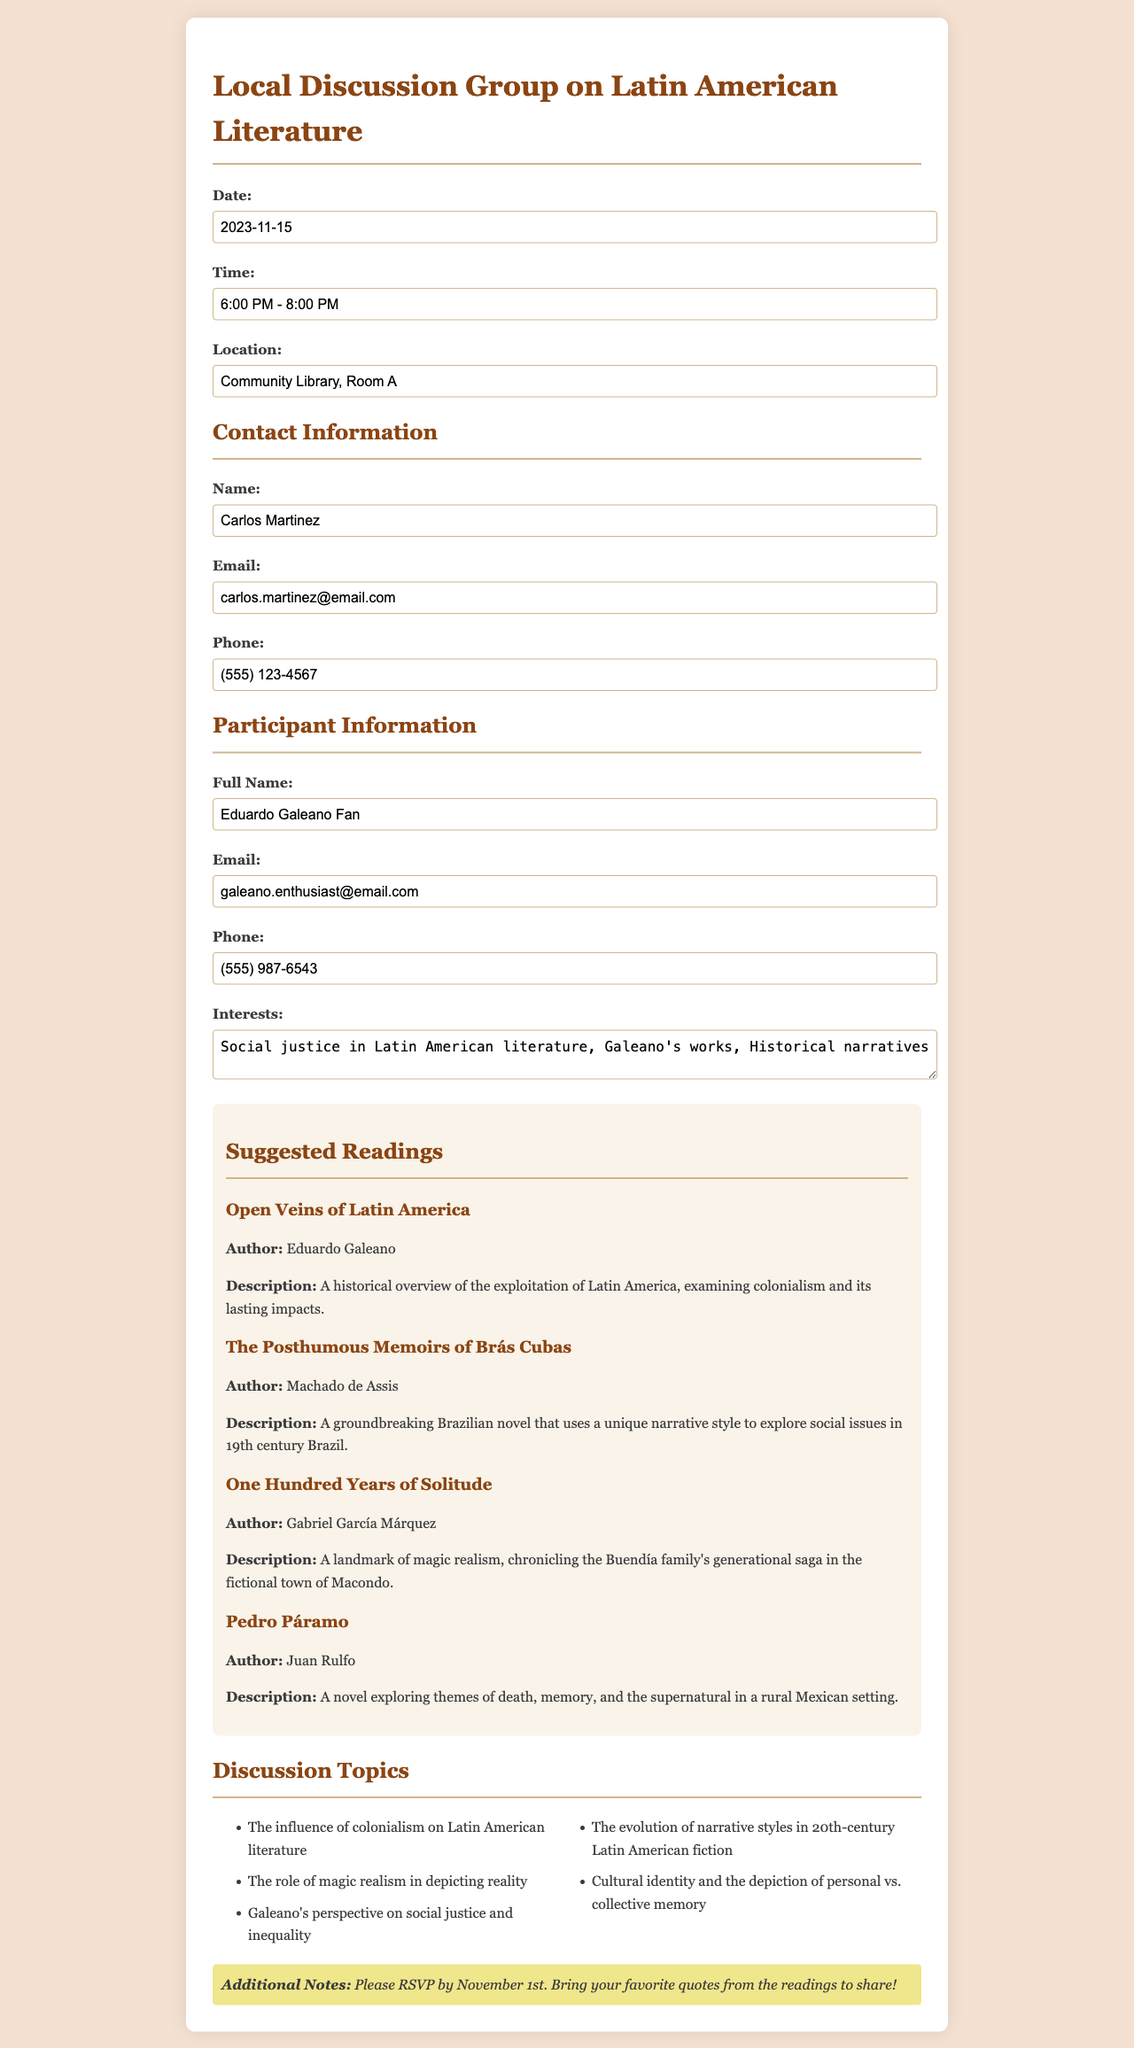What is the date of the event? The date of the event is specified in the document under the event details section.
Answer: 2023-11-15 What time does the discussion group start? The time of the discussion group is provided in the event details section.
Answer: 6:00 PM - 8:00 PM Where is the location of the event? The location is mentioned in the part detailing the event information.
Answer: Community Library, Room A Who is the contact person for the event? The contact person is indicated under the contact information section of the document.
Answer: Carlos Martinez What is one of the suggested readings? The document lists several suggested readings in the reading list section.
Answer: Open Veins of Latin America Which author's works are specifically mentioned in the interests? The interests listed include discussions about a particular author's works, which is noted in the participant information section.
Answer: Galeano's works What is the email of the participant? The participant's email is provided in the contact information section of the participant information.
Answer: galeano.enthusiast@email.com What is one of the discussion topics? The document includes a list of discussion topics relevant to the literature of Latin America.
Answer: The influence of colonialism on Latin American literature What should participants bring to the event? The additional notes section mentions what participants should bring.
Answer: Favorite quotes from the readings 